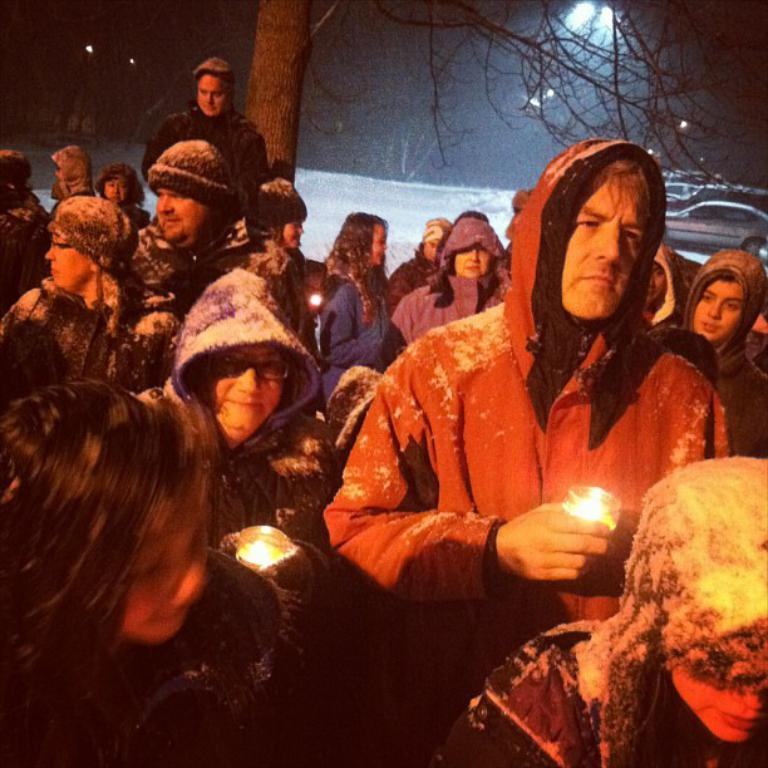Who or what can be seen in the image? There are people in the image. What are some of the people holding? Some of the people are holding candles. What natural element is present in the image? There is a tree in the image. What type of man-made objects can be seen in the image? There are vehicles in the image. What can be seen in the distance in the image? The sky is visible in the background of the image. Can you see the kitty sliding down the slope in the image? There is no kitty or slope present in the image. 